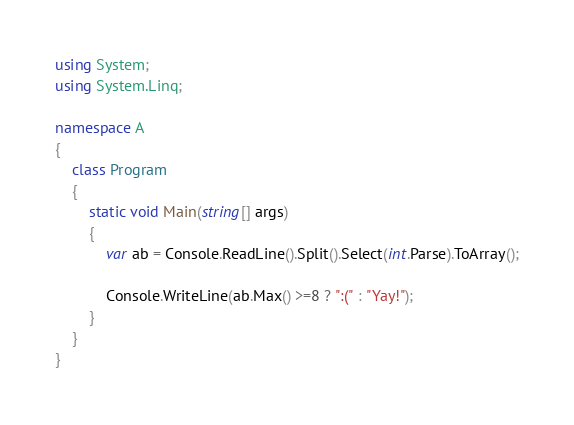Convert code to text. <code><loc_0><loc_0><loc_500><loc_500><_C#_>using System;
using System.Linq;

namespace A
{
    class Program
    {
        static void Main(string[] args)
        {
            var ab = Console.ReadLine().Split().Select(int.Parse).ToArray();
            
            Console.WriteLine(ab.Max() >=8 ? ":(" : "Yay!");
        }
    }
}
</code> 